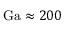Convert formula to latex. <formula><loc_0><loc_0><loc_500><loc_500>G a \approx 2 0 0</formula> 